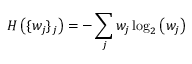<formula> <loc_0><loc_0><loc_500><loc_500>H \left ( \{ w _ { j } \} _ { j } \right ) = - \sum _ { j } w _ { j } \log _ { 2 } \left ( w _ { j } \right )</formula> 